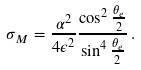<formula> <loc_0><loc_0><loc_500><loc_500>\sigma _ { M } = \frac { \alpha ^ { 2 } } { 4 \epsilon ^ { 2 } } \frac { \cos ^ { 2 } \frac { \theta _ { e } } { 2 } } { \sin ^ { 4 } \frac { \theta _ { e } } { 2 } } \, .</formula> 